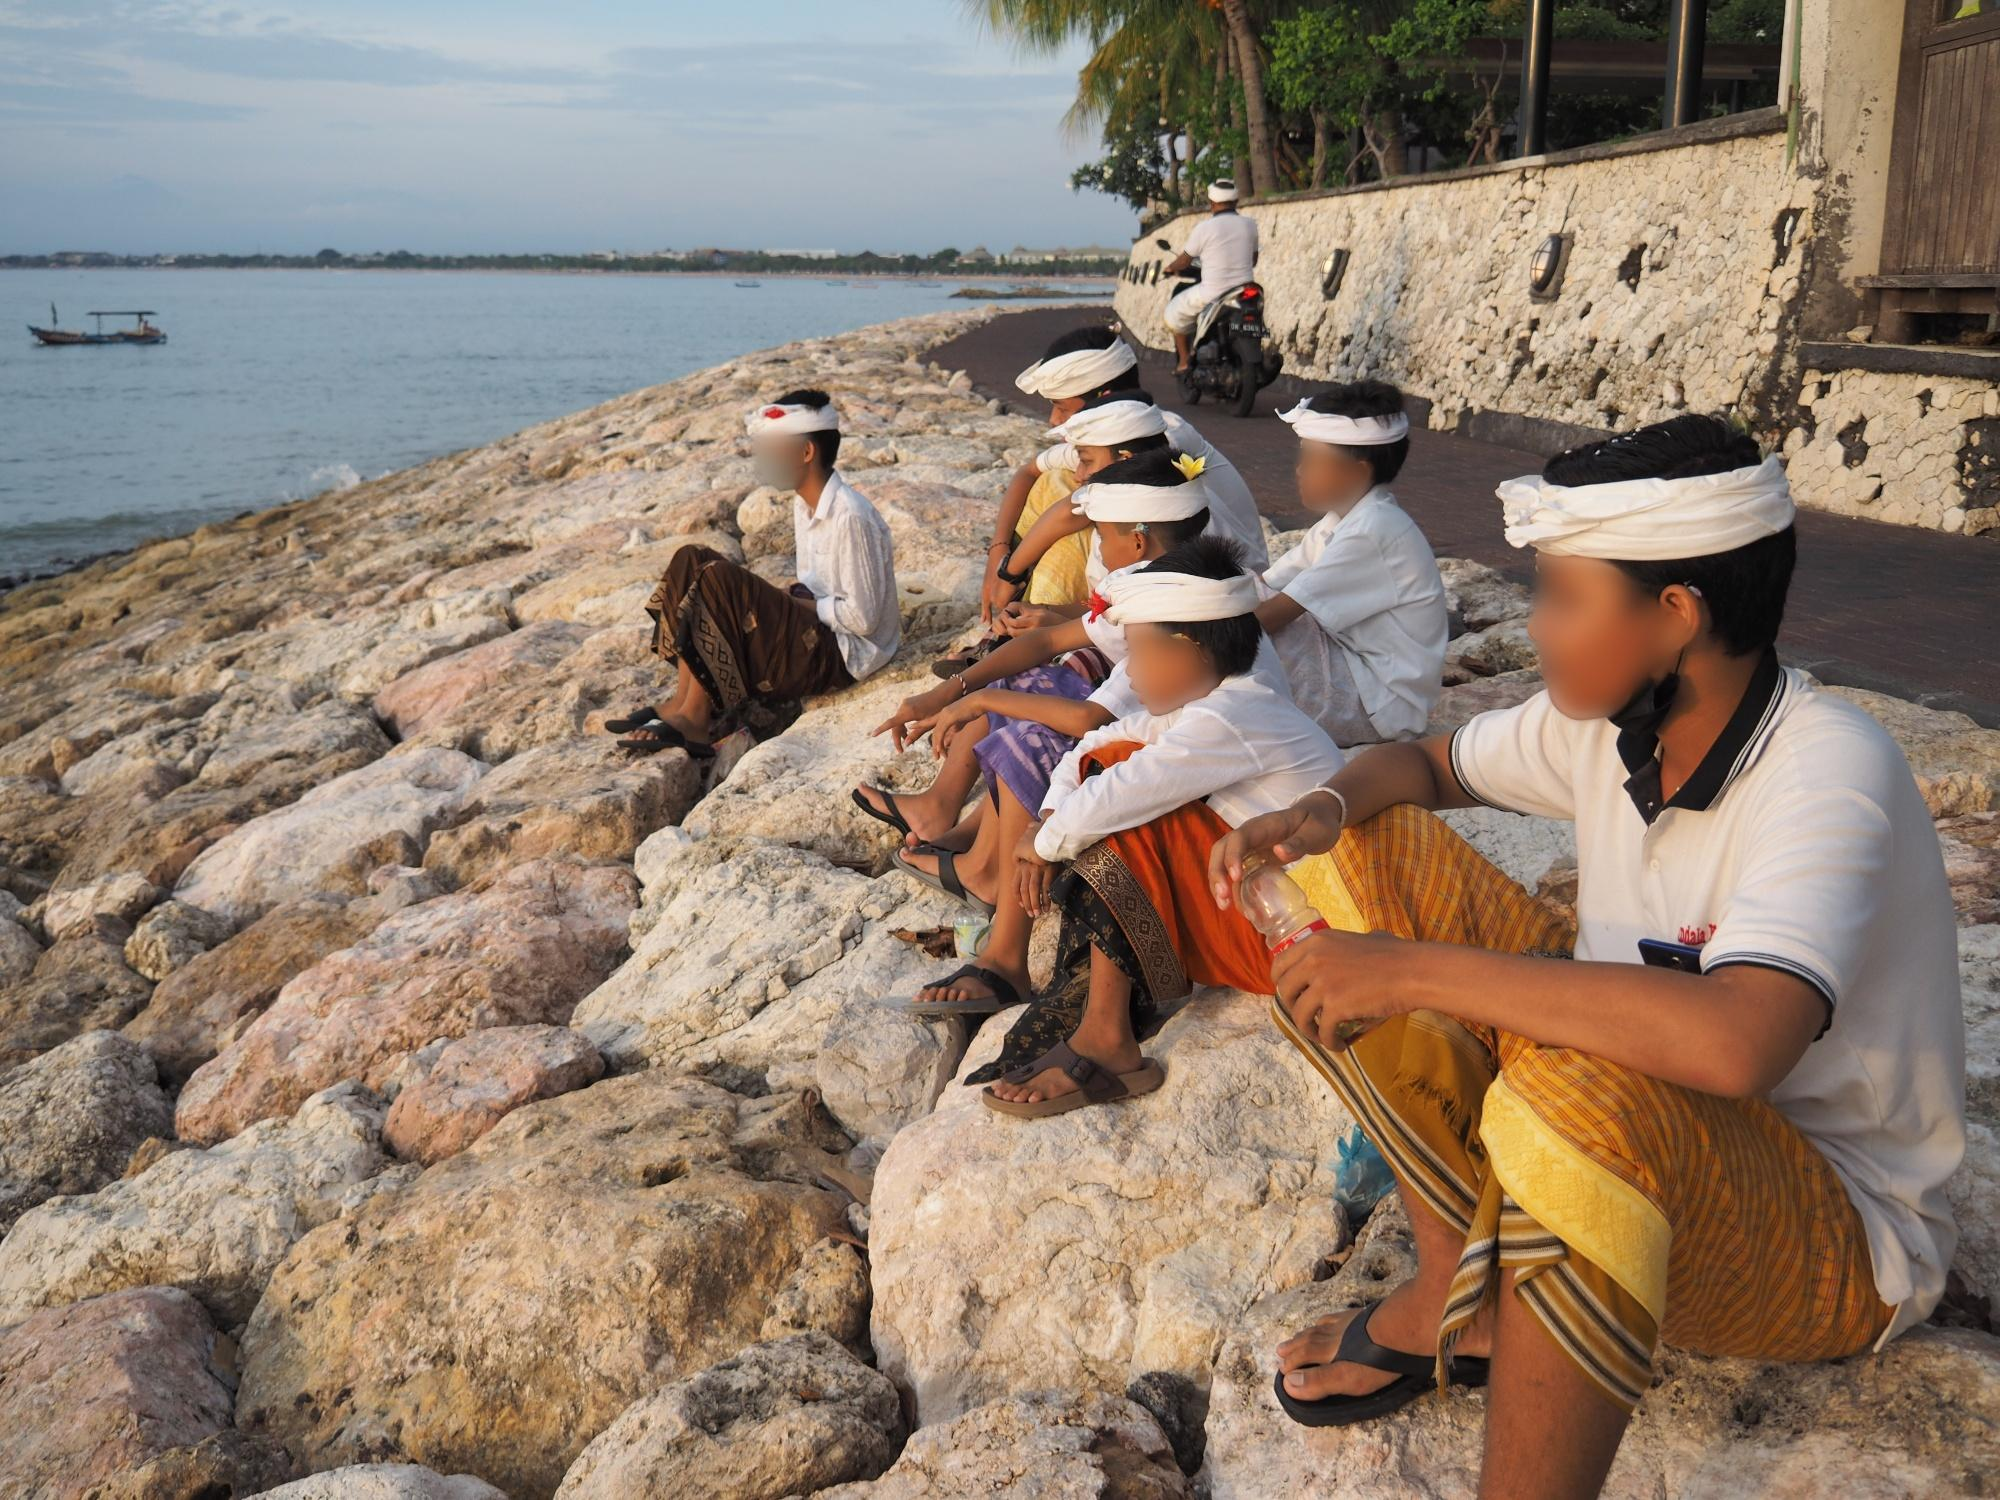Describe a day in the life of one of the individuals in this image. A typical day for Ayu, one of the young women in the image, begins at dawn. She helps with family chores, prepares offerings, and participates in morning prayers at the family's shrine. As the day progresses, she attends to her studies, learning traditional dance and music, while assisting her parents with their small business. In the afternoon, Ayu joins a community group to prepare for upcoming ceremonies, crafting intricate decorations and offerings. As the sun sets, she and her friends gather by the shore for a moment of relaxation and reflection, connecting with their shared heritage and the tranquil beauty of their coastal home. Create a poem that captures the essence of this image. On Bali's rugged shore they sit, 
In hues so rich, traditions knit, 
With ocean’s breath and calm embrace, 
Time stands still in this sacred place.

Their garments bright, with history's thread, 
Each pattern tells what’s left unsaid, 
Beneath the sky where dreams alight, 
They find their peace in fading light.

A union of the shore and sea, 
In quiet moments, spirits free, 
Cultures blend with nature’s grace, 
In tranquil hearts, they find their place. 